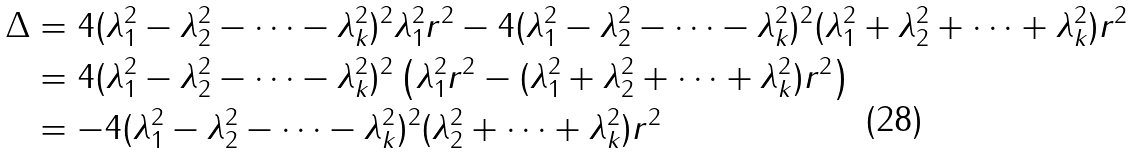Convert formula to latex. <formula><loc_0><loc_0><loc_500><loc_500>\Delta & = 4 ( \lambda _ { 1 } ^ { 2 } - \lambda _ { 2 } ^ { 2 } - \cdots - \lambda _ { k } ^ { 2 } ) ^ { 2 } \lambda _ { 1 } ^ { 2 } r ^ { 2 } - 4 ( \lambda _ { 1 } ^ { 2 } - \lambda _ { 2 } ^ { 2 } - \cdots - \lambda _ { k } ^ { 2 } ) ^ { 2 } ( \lambda _ { 1 } ^ { 2 } + \lambda _ { 2 } ^ { 2 } + \cdots + \lambda _ { k } ^ { 2 } ) r ^ { 2 } \\ & = 4 ( \lambda _ { 1 } ^ { 2 } - \lambda _ { 2 } ^ { 2 } - \cdots - \lambda _ { k } ^ { 2 } ) ^ { 2 } \left ( \lambda _ { 1 } ^ { 2 } r ^ { 2 } - ( \lambda _ { 1 } ^ { 2 } + \lambda _ { 2 } ^ { 2 } + \cdots + \lambda _ { k } ^ { 2 } ) r ^ { 2 } \right ) \\ & = - 4 ( \lambda _ { 1 } ^ { 2 } - \lambda _ { 2 } ^ { 2 } - \cdots - \lambda _ { k } ^ { 2 } ) ^ { 2 } ( \lambda _ { 2 } ^ { 2 } + \cdots + \lambda _ { k } ^ { 2 } ) r ^ { 2 }</formula> 